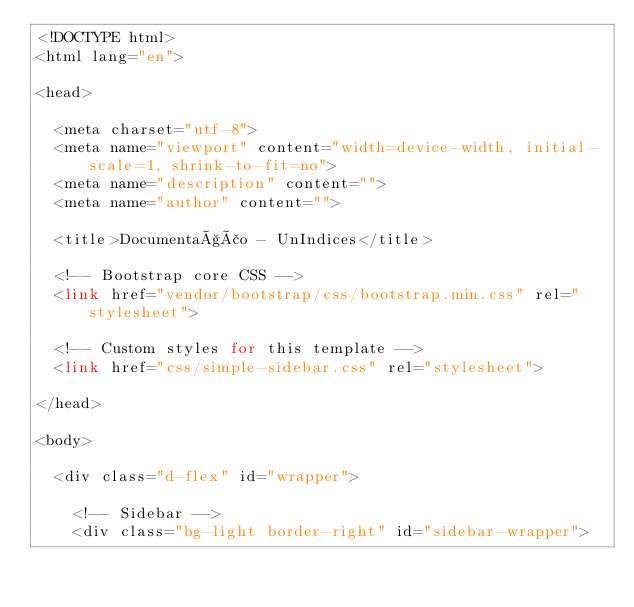<code> <loc_0><loc_0><loc_500><loc_500><_PHP_><!DOCTYPE html>
<html lang="en">

<head>

  <meta charset="utf-8">
  <meta name="viewport" content="width=device-width, initial-scale=1, shrink-to-fit=no">
  <meta name="description" content="">
  <meta name="author" content="">

  <title>Documentação - UnIndices</title>

  <!-- Bootstrap core CSS -->
  <link href="vendor/bootstrap/css/bootstrap.min.css" rel="stylesheet">

  <!-- Custom styles for this template -->
  <link href="css/simple-sidebar.css" rel="stylesheet">

</head>

<body>

  <div class="d-flex" id="wrapper">

    <!-- Sidebar -->
    <div class="bg-light border-right" id="sidebar-wrapper"></code> 